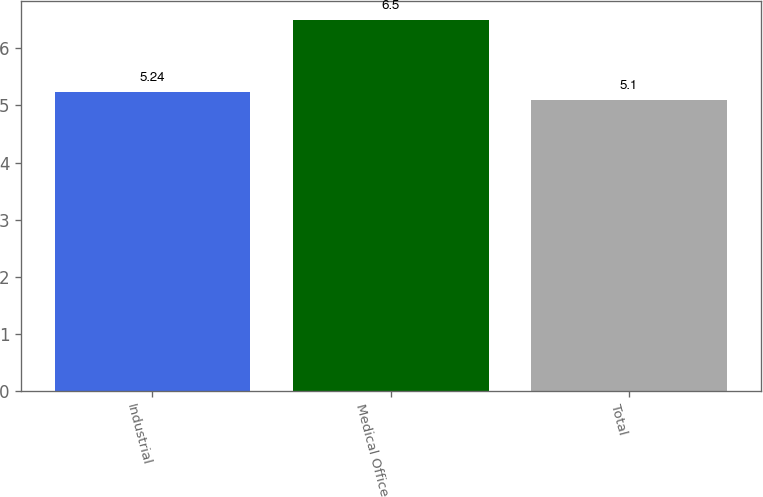Convert chart. <chart><loc_0><loc_0><loc_500><loc_500><bar_chart><fcel>Industrial<fcel>Medical Office<fcel>Total<nl><fcel>5.24<fcel>6.5<fcel>5.1<nl></chart> 